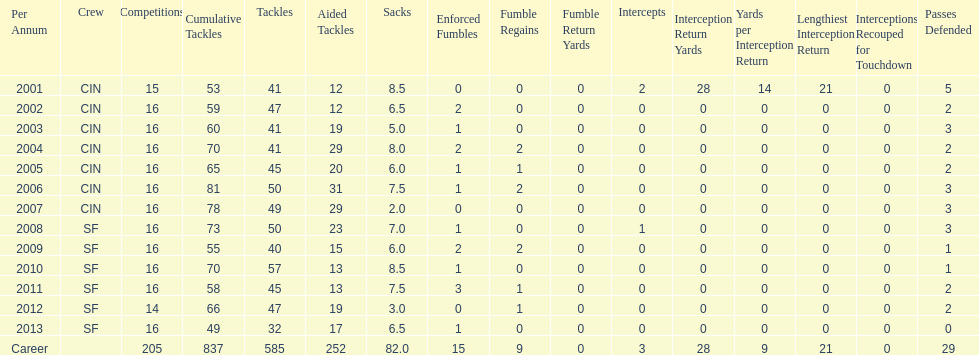What is the only season he has fewer than three sacks? 2007. Would you be able to parse every entry in this table? {'header': ['Per Annum', 'Crew', 'Competitions', 'Cumulative Tackles', 'Tackles', 'Aided Tackles', 'Sacks', 'Enforced Fumbles', 'Fumble Regains', 'Fumble Return Yards', 'Intercepts', 'Interception Return Yards', 'Yards per Interception Return', 'Lengthiest Interception Return', 'Interceptions Recouped for Touchdown', 'Passes Defended'], 'rows': [['2001', 'CIN', '15', '53', '41', '12', '8.5', '0', '0', '0', '2', '28', '14', '21', '0', '5'], ['2002', 'CIN', '16', '59', '47', '12', '6.5', '2', '0', '0', '0', '0', '0', '0', '0', '2'], ['2003', 'CIN', '16', '60', '41', '19', '5.0', '1', '0', '0', '0', '0', '0', '0', '0', '3'], ['2004', 'CIN', '16', '70', '41', '29', '8.0', '2', '2', '0', '0', '0', '0', '0', '0', '2'], ['2005', 'CIN', '16', '65', '45', '20', '6.0', '1', '1', '0', '0', '0', '0', '0', '0', '2'], ['2006', 'CIN', '16', '81', '50', '31', '7.5', '1', '2', '0', '0', '0', '0', '0', '0', '3'], ['2007', 'CIN', '16', '78', '49', '29', '2.0', '0', '0', '0', '0', '0', '0', '0', '0', '3'], ['2008', 'SF', '16', '73', '50', '23', '7.0', '1', '0', '0', '1', '0', '0', '0', '0', '3'], ['2009', 'SF', '16', '55', '40', '15', '6.0', '2', '2', '0', '0', '0', '0', '0', '0', '1'], ['2010', 'SF', '16', '70', '57', '13', '8.5', '1', '0', '0', '0', '0', '0', '0', '0', '1'], ['2011', 'SF', '16', '58', '45', '13', '7.5', '3', '1', '0', '0', '0', '0', '0', '0', '2'], ['2012', 'SF', '14', '66', '47', '19', '3.0', '0', '1', '0', '0', '0', '0', '0', '0', '2'], ['2013', 'SF', '16', '49', '32', '17', '6.5', '1', '0', '0', '0', '0', '0', '0', '0', '0'], ['Career', '', '205', '837', '585', '252', '82.0', '15', '9', '0', '3', '28', '9', '21', '0', '29']]} 